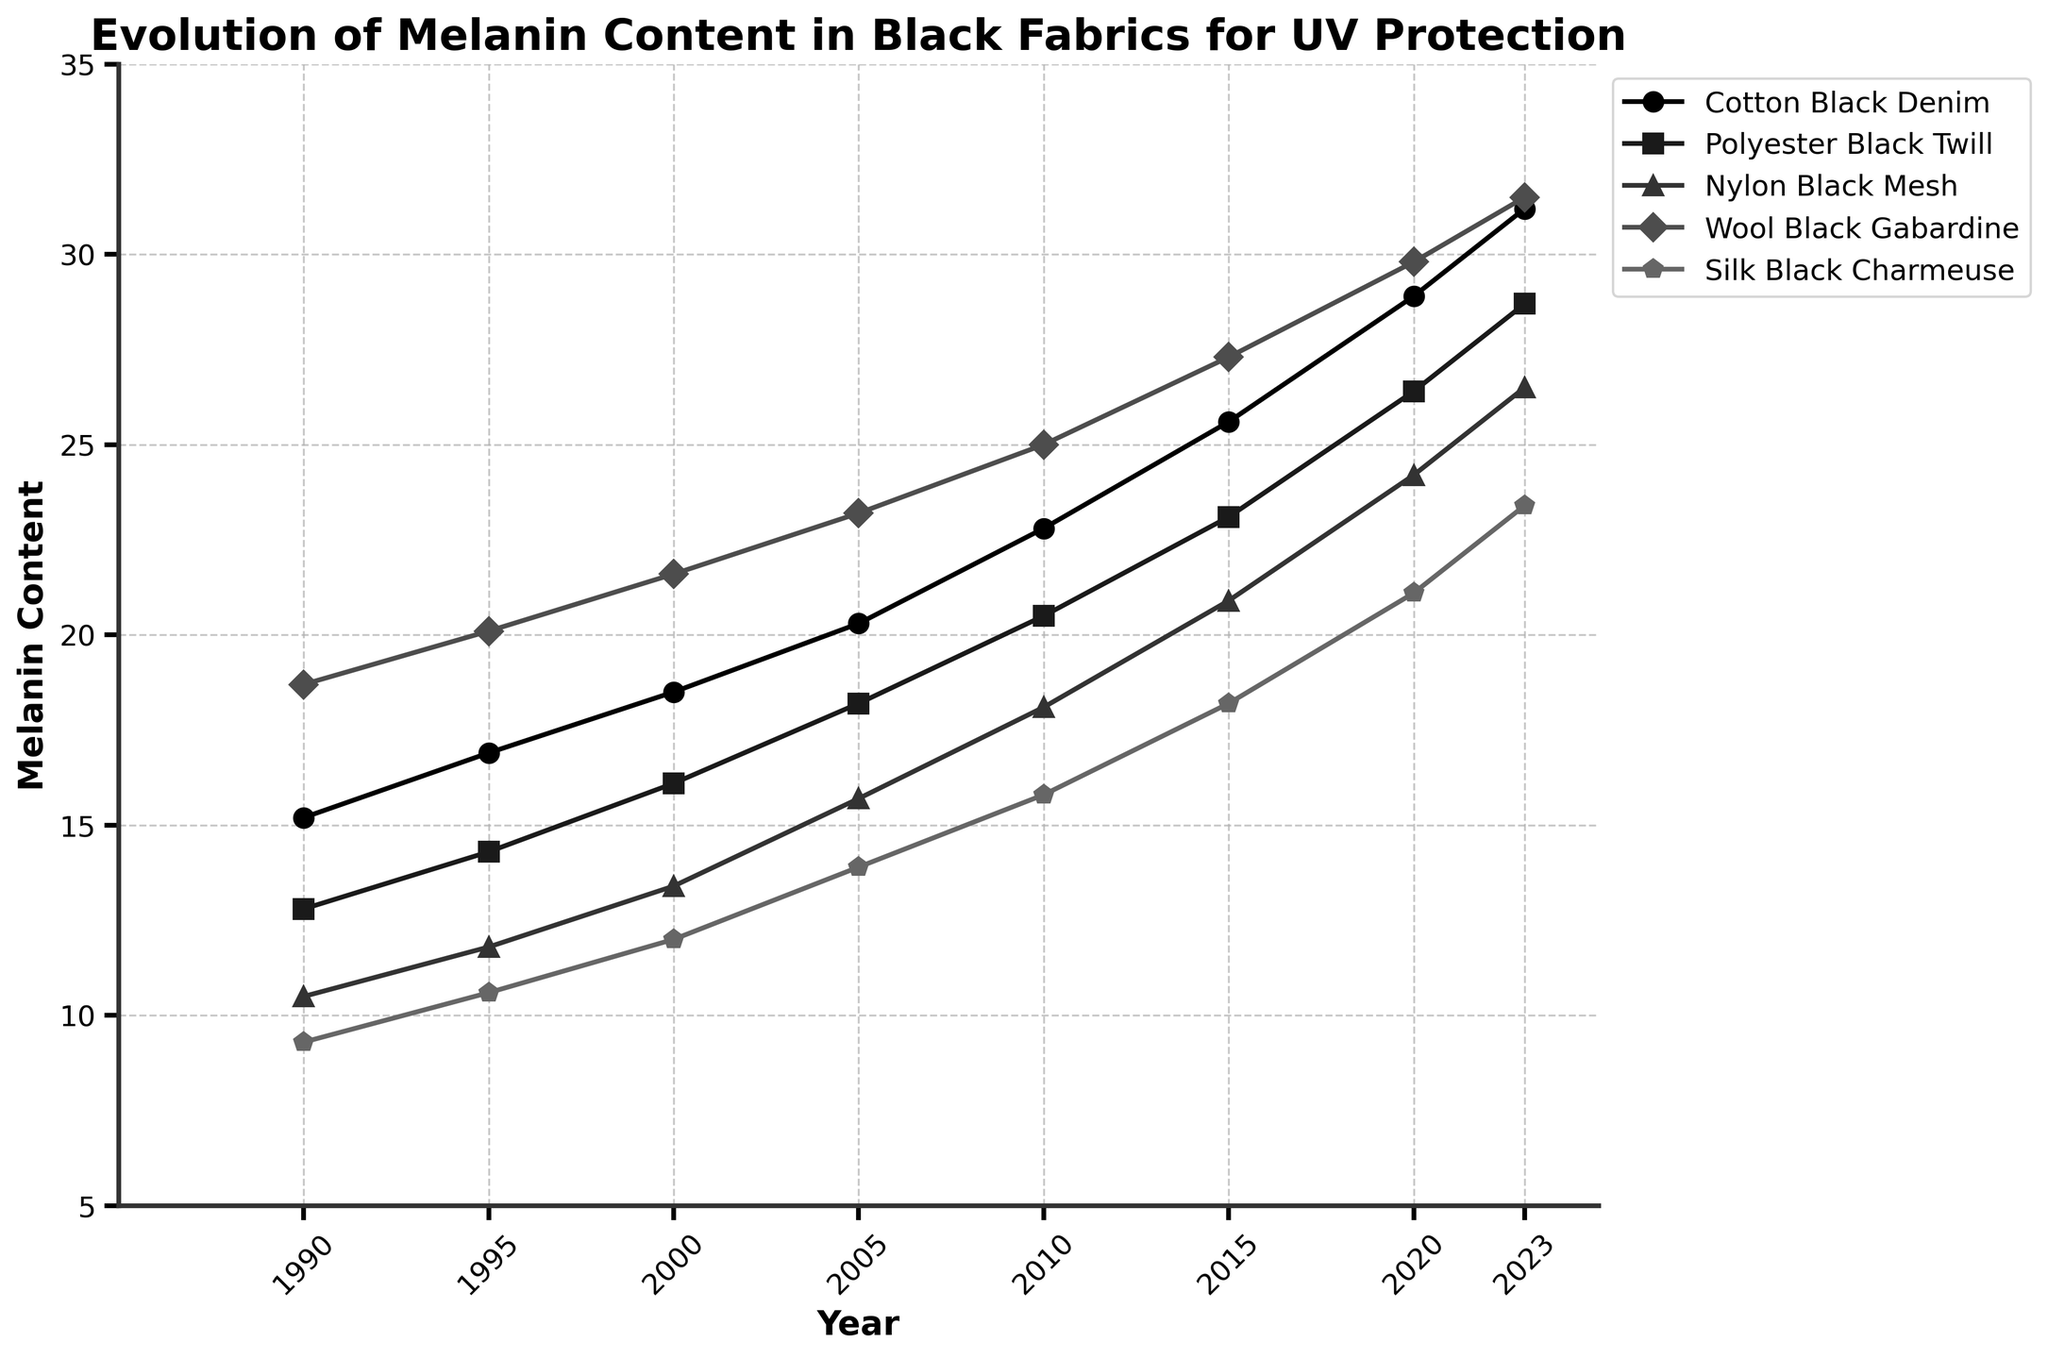What is the overall trend in the melanin content of Cotton Black Denim from 1990 to 2023? The melanin content in Cotton Black Denim shows a consistent increase over the years. Starting from 15.2 in 1990, it gradually rises to 31.2 by 2023.
Answer: Consistent increase Which fabric showed the highest melanin content in 2023? In 2023, Wool Black Gabardine has the highest melanin content, with a value of 31.5.
Answer: Wool Black Gabardine By how much did the melanin content of Polyester Black Twill increase from 2000 to 2020? The melanin content in Polyester Black Twill in 2000 was 16.1. By 2020, it increased to 26.4. The difference is 26.4 - 16.1 = 10.3.
Answer: 10.3 Which year had the smallest gap in melanin content between Nylon Black Mesh and Silk Black Charmeuse? In 2000, the melanin content of Nylon Black Mesh was 13.4 and Silk Black Charmeuse was 12.0, making the gap 1.4, which is the smallest among all years.
Answer: 2000 What is the average melanin content of Wool Black Gabardine over the years displayed? Adding up the melanin content of Wool Black Gabardine over the years: 18.7 + 20.1 + 21.6 + 23.2 + 25.0 + 27.3 + 29.8 + 31.5 gives 197.2. Since there are 8 entries, the average is 197.2 / 8 = 24.65.
Answer: 24.65 What is the difference in melanin content between the fabric with the highest and lowest values in 2010? In 2010, Wool Black Gabardine has the highest melanin content (25.0), and Silk Black Charmeuse has the lowest (15.8). The difference is 25.0 - 15.8 = 9.2.
Answer: 9.2 How much did the melanin content in Silk Black Charmeuse increase from 1995 to 2015? The melanin content in Silk Black Charmeuse in 1995 was 10.6, and by 2015 it increased to 18.2. The difference is 18.2 - 10.6 = 7.6.
Answer: 7.6 In which year did all fabrics exceed a melanin content of 20? By observing the data, in 2020, all fabrics exceed a melanin content of 20: Cotton Black Denim (28.9), Polyester Black Twill (26.4), Nylon Black Mesh (24.2), Wool Black Gabardine (29.8), and Silk Black Charmeuse (21.1).
Answer: 2020 